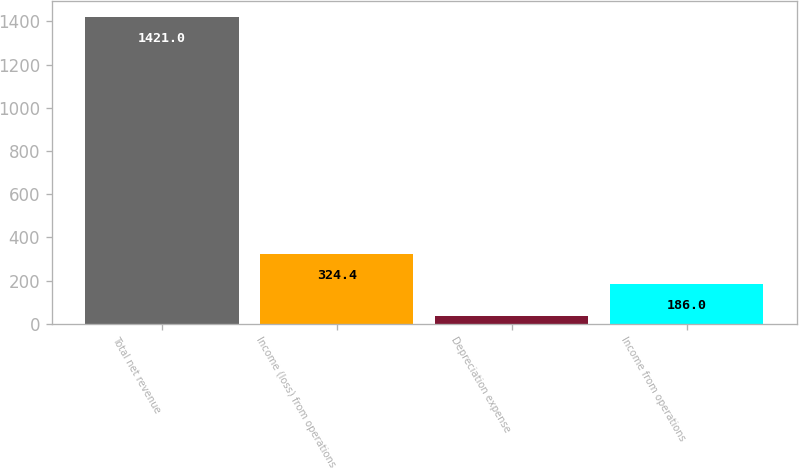Convert chart. <chart><loc_0><loc_0><loc_500><loc_500><bar_chart><fcel>Total net revenue<fcel>Income (loss) from operations<fcel>Depreciation expense<fcel>Income from operations<nl><fcel>1421<fcel>324.4<fcel>37<fcel>186<nl></chart> 